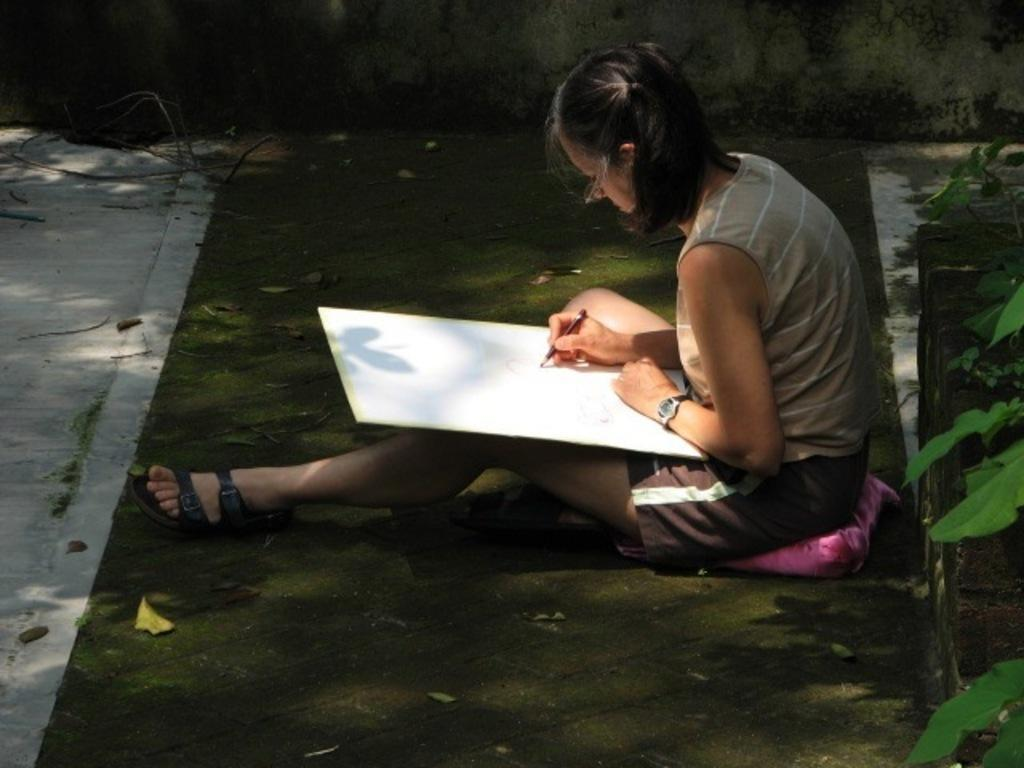Who is the main subject in the picture? There is a woman in the picture. What is the woman doing in the image? The woman is sitting and holding a board. What is the woman doing with the board? The woman is writing on the board. What type of doll is the woman using to write on the board? There is no doll present in the image, and the woman is using a board, not a doll, to write on. 